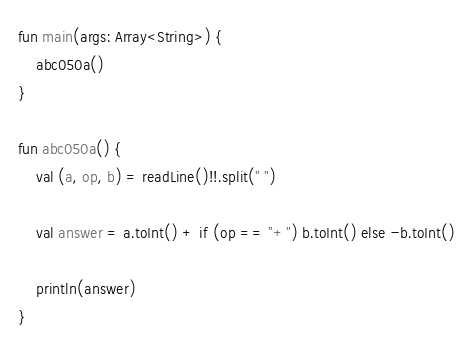Convert code to text. <code><loc_0><loc_0><loc_500><loc_500><_Kotlin_>fun main(args: Array<String>) {
    abc050a()
}

fun abc050a() {
    val (a, op, b) = readLine()!!.split(" ")

    val answer = a.toInt() + if (op == "+") b.toInt() else -b.toInt()

    println(answer)
}
</code> 